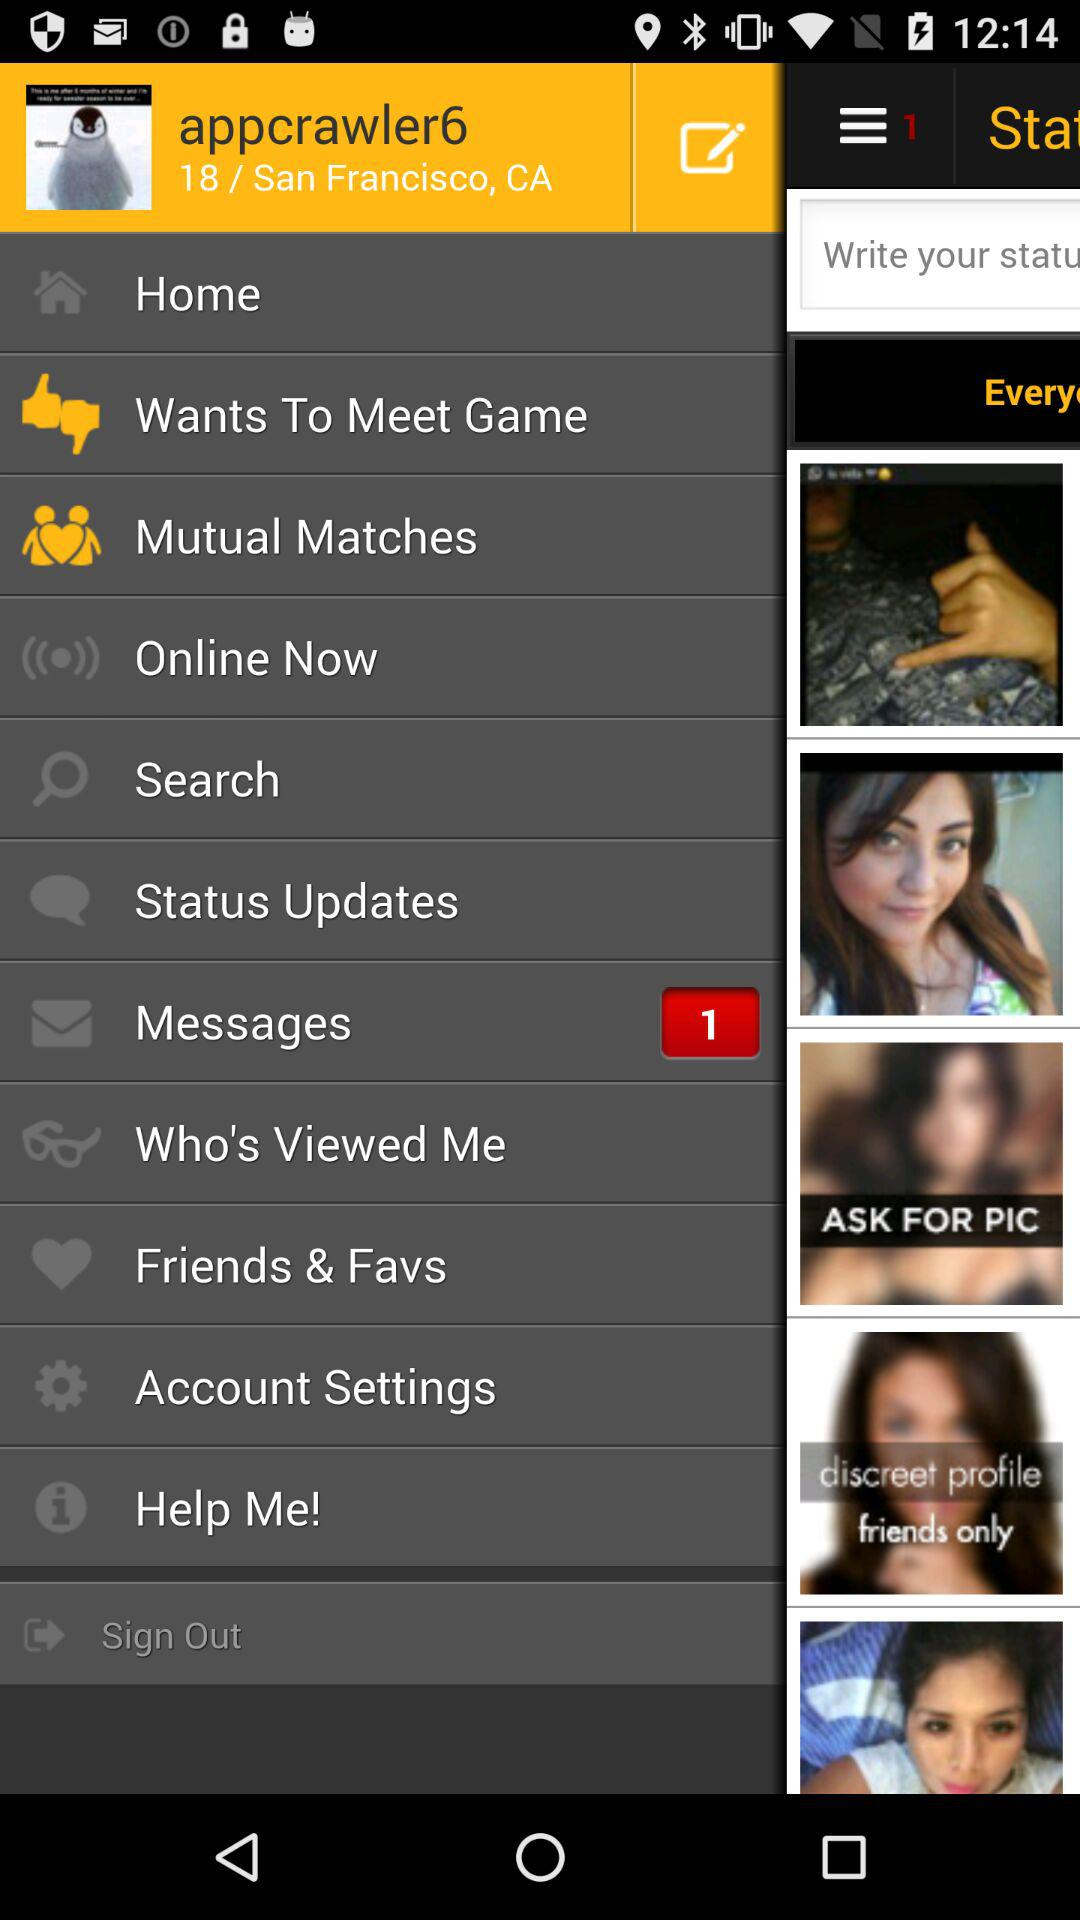What city is the user from? The user is from "San Francisco". 